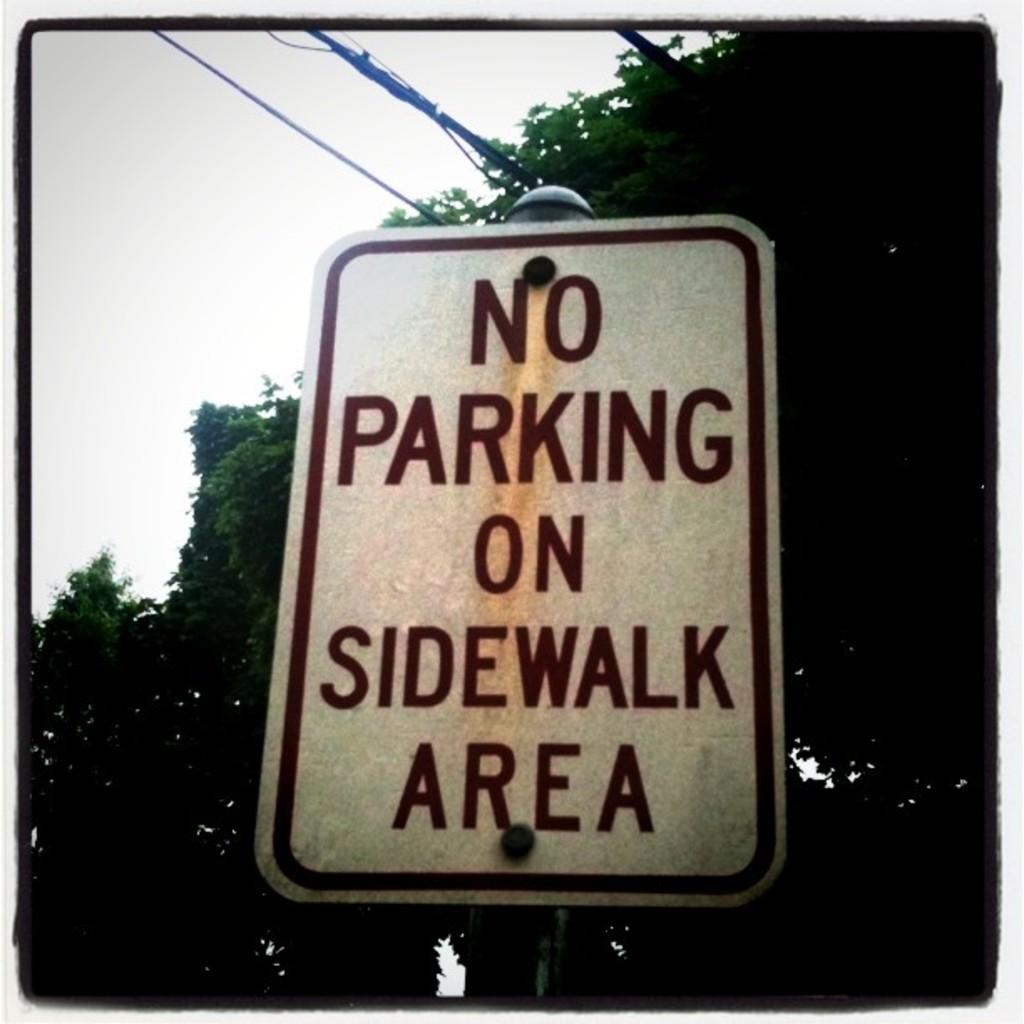According to this sign what is not allowed on the sidewalk area?
Keep it short and to the point. Parking. 